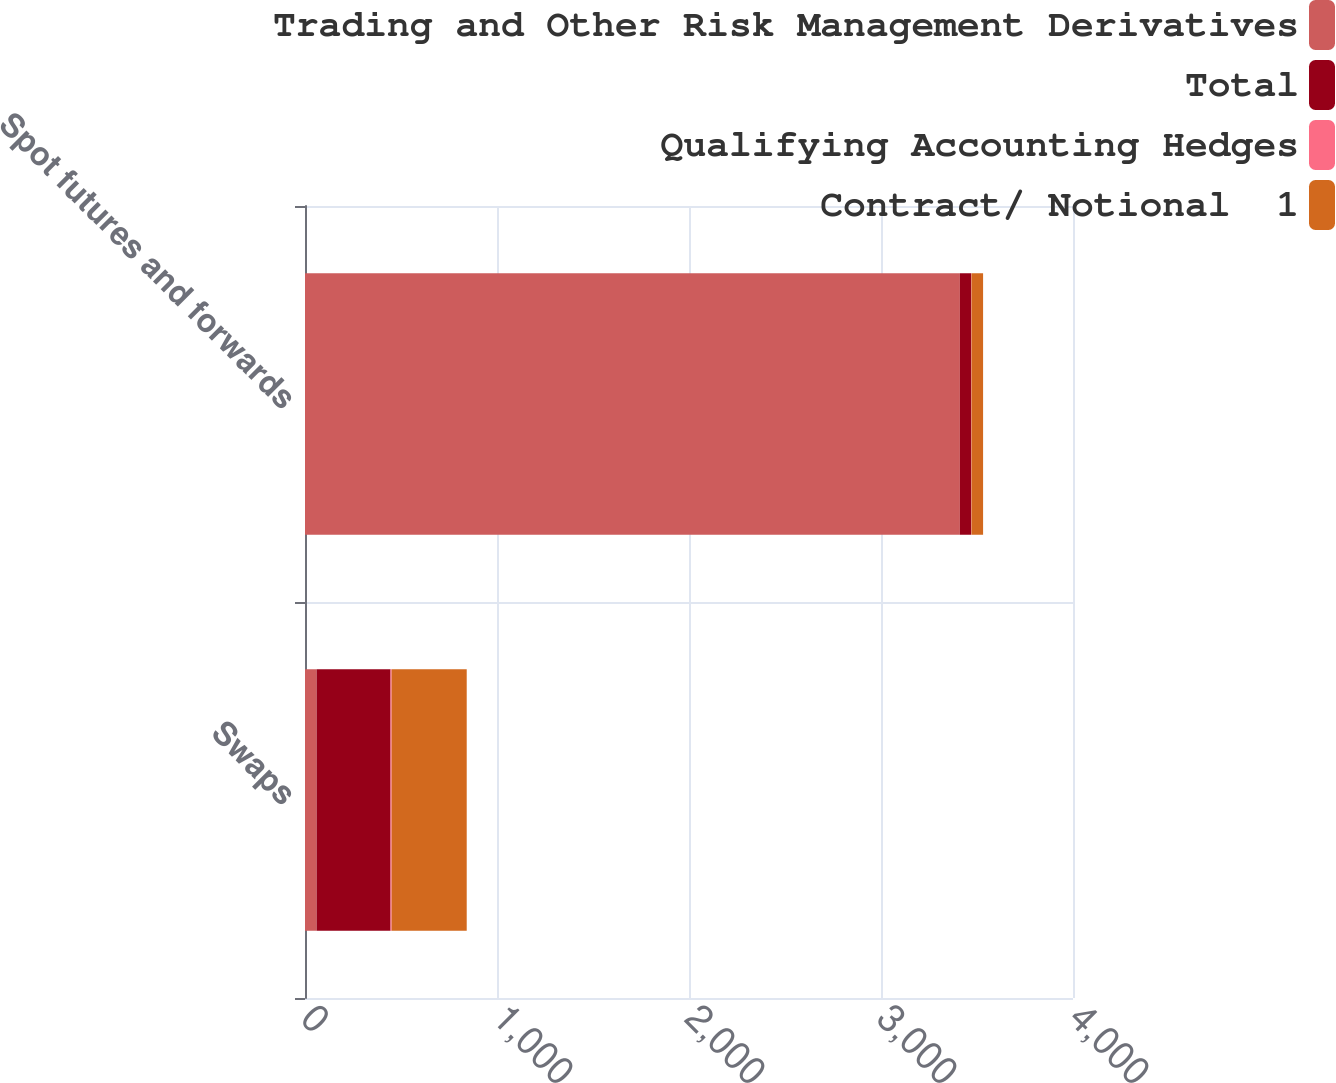Convert chart. <chart><loc_0><loc_0><loc_500><loc_500><stacked_bar_chart><ecel><fcel>Swaps<fcel>Spot futures and forwards<nl><fcel>Trading and Other Risk Management Derivatives<fcel>60.5<fcel>3410.7<nl><fcel>Total<fcel>385<fcel>58.8<nl><fcel>Qualifying Accounting Hedges<fcel>5.9<fcel>1.7<nl><fcel>Contract/ Notional  1<fcel>390.9<fcel>60.5<nl></chart> 